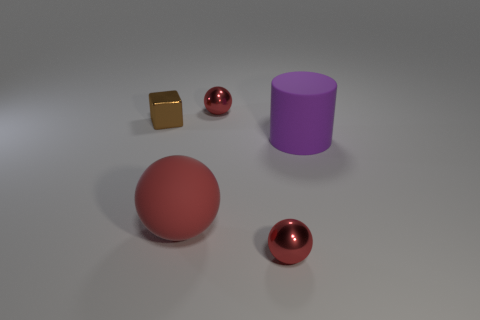Subtract all red matte spheres. How many spheres are left? 2 Add 3 large cyan matte things. How many objects exist? 8 Subtract 1 cylinders. How many cylinders are left? 0 Subtract all blocks. How many objects are left? 4 Add 4 tiny metallic balls. How many tiny metallic balls are left? 6 Add 3 tiny gray metal cubes. How many tiny gray metal cubes exist? 3 Subtract 0 red cylinders. How many objects are left? 5 Subtract all blue spheres. Subtract all cyan cylinders. How many spheres are left? 3 Subtract all purple blocks. How many green cylinders are left? 0 Subtract all brown things. Subtract all red metallic things. How many objects are left? 2 